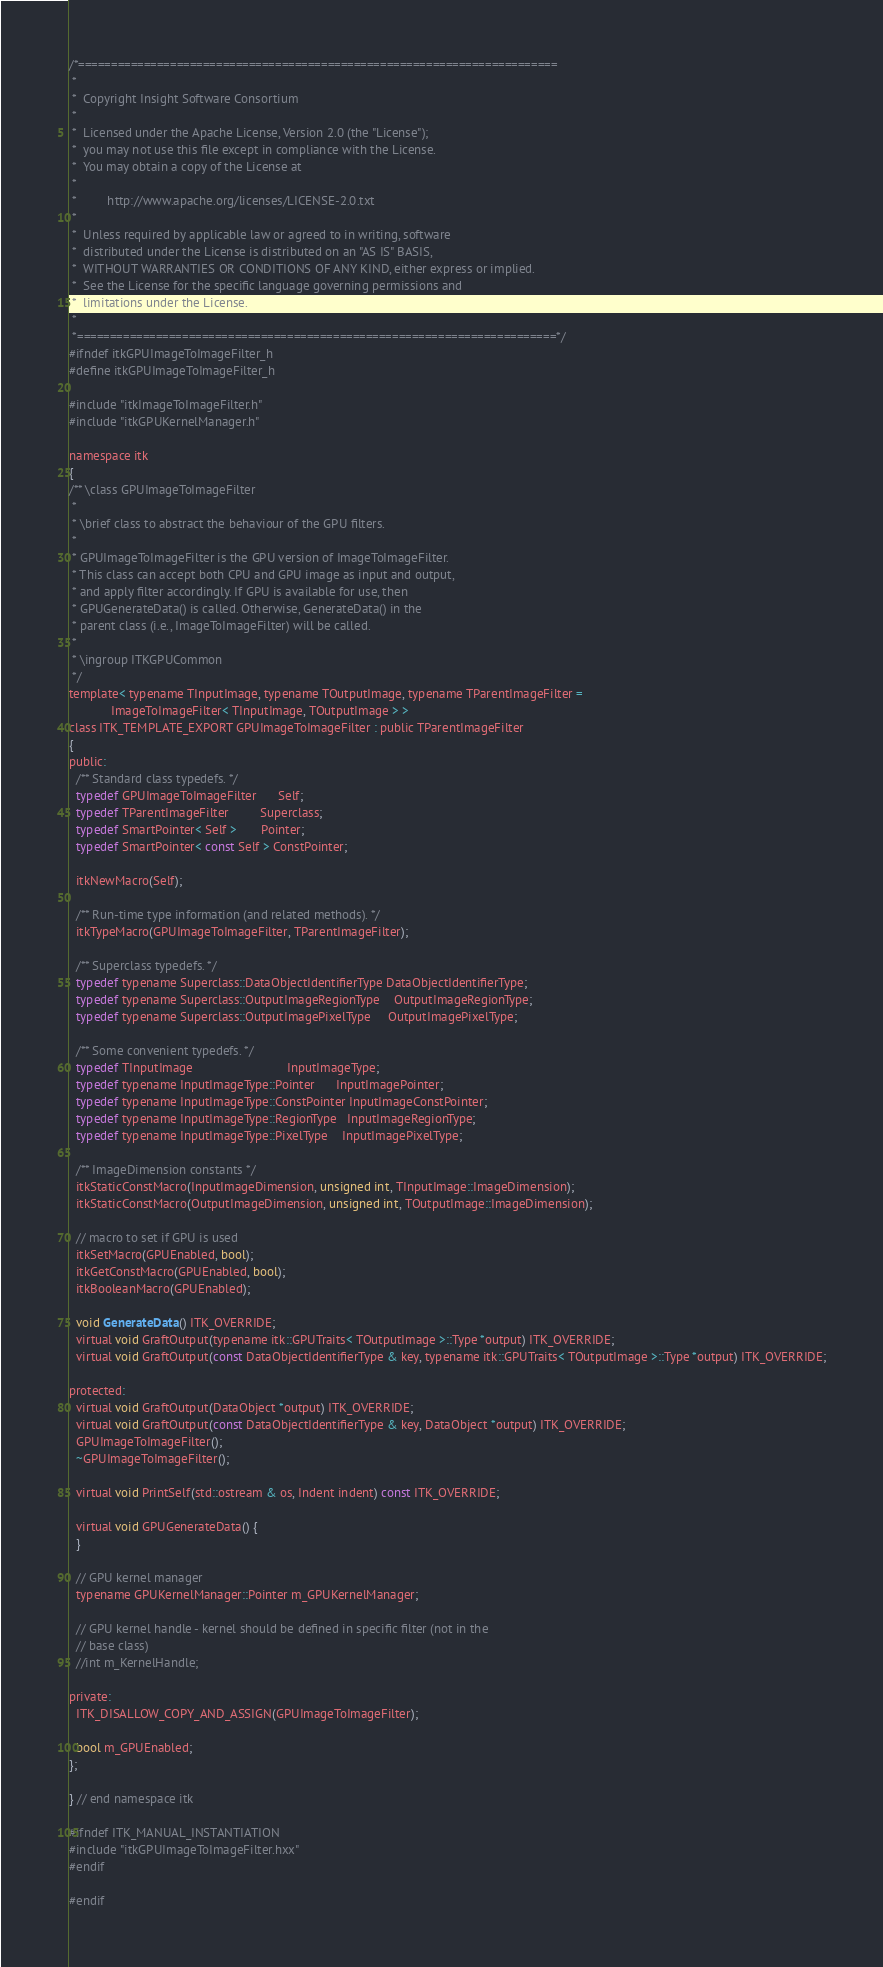Convert code to text. <code><loc_0><loc_0><loc_500><loc_500><_C_>/*=========================================================================
 *
 *  Copyright Insight Software Consortium
 *
 *  Licensed under the Apache License, Version 2.0 (the "License");
 *  you may not use this file except in compliance with the License.
 *  You may obtain a copy of the License at
 *
 *         http://www.apache.org/licenses/LICENSE-2.0.txt
 *
 *  Unless required by applicable law or agreed to in writing, software
 *  distributed under the License is distributed on an "AS IS" BASIS,
 *  WITHOUT WARRANTIES OR CONDITIONS OF ANY KIND, either express or implied.
 *  See the License for the specific language governing permissions and
 *  limitations under the License.
 *
 *=========================================================================*/
#ifndef itkGPUImageToImageFilter_h
#define itkGPUImageToImageFilter_h

#include "itkImageToImageFilter.h"
#include "itkGPUKernelManager.h"

namespace itk
{
/** \class GPUImageToImageFilter
 *
 * \brief class to abstract the behaviour of the GPU filters.
 *
 * GPUImageToImageFilter is the GPU version of ImageToImageFilter.
 * This class can accept both CPU and GPU image as input and output,
 * and apply filter accordingly. If GPU is available for use, then
 * GPUGenerateData() is called. Otherwise, GenerateData() in the
 * parent class (i.e., ImageToImageFilter) will be called.
 *
 * \ingroup ITKGPUCommon
 */
template< typename TInputImage, typename TOutputImage, typename TParentImageFilter =
            ImageToImageFilter< TInputImage, TOutputImage > >
class ITK_TEMPLATE_EXPORT GPUImageToImageFilter : public TParentImageFilter
{
public:
  /** Standard class typedefs. */
  typedef GPUImageToImageFilter      Self;
  typedef TParentImageFilter         Superclass;
  typedef SmartPointer< Self >       Pointer;
  typedef SmartPointer< const Self > ConstPointer;

  itkNewMacro(Self);

  /** Run-time type information (and related methods). */
  itkTypeMacro(GPUImageToImageFilter, TParentImageFilter);

  /** Superclass typedefs. */
  typedef typename Superclass::DataObjectIdentifierType DataObjectIdentifierType;
  typedef typename Superclass::OutputImageRegionType    OutputImageRegionType;
  typedef typename Superclass::OutputImagePixelType     OutputImagePixelType;

  /** Some convenient typedefs. */
  typedef TInputImage                           InputImageType;
  typedef typename InputImageType::Pointer      InputImagePointer;
  typedef typename InputImageType::ConstPointer InputImageConstPointer;
  typedef typename InputImageType::RegionType   InputImageRegionType;
  typedef typename InputImageType::PixelType    InputImagePixelType;

  /** ImageDimension constants */
  itkStaticConstMacro(InputImageDimension, unsigned int, TInputImage::ImageDimension);
  itkStaticConstMacro(OutputImageDimension, unsigned int, TOutputImage::ImageDimension);

  // macro to set if GPU is used
  itkSetMacro(GPUEnabled, bool);
  itkGetConstMacro(GPUEnabled, bool);
  itkBooleanMacro(GPUEnabled);

  void GenerateData() ITK_OVERRIDE;
  virtual void GraftOutput(typename itk::GPUTraits< TOutputImage >::Type *output) ITK_OVERRIDE;
  virtual void GraftOutput(const DataObjectIdentifierType & key, typename itk::GPUTraits< TOutputImage >::Type *output) ITK_OVERRIDE;

protected:
  virtual void GraftOutput(DataObject *output) ITK_OVERRIDE;
  virtual void GraftOutput(const DataObjectIdentifierType & key, DataObject *output) ITK_OVERRIDE;
  GPUImageToImageFilter();
  ~GPUImageToImageFilter();

  virtual void PrintSelf(std::ostream & os, Indent indent) const ITK_OVERRIDE;

  virtual void GPUGenerateData() {
  }

  // GPU kernel manager
  typename GPUKernelManager::Pointer m_GPUKernelManager;

  // GPU kernel handle - kernel should be defined in specific filter (not in the
  // base class)
  //int m_KernelHandle;

private:
  ITK_DISALLOW_COPY_AND_ASSIGN(GPUImageToImageFilter);

  bool m_GPUEnabled;
};

} // end namespace itk

#ifndef ITK_MANUAL_INSTANTIATION
#include "itkGPUImageToImageFilter.hxx"
#endif

#endif
</code> 